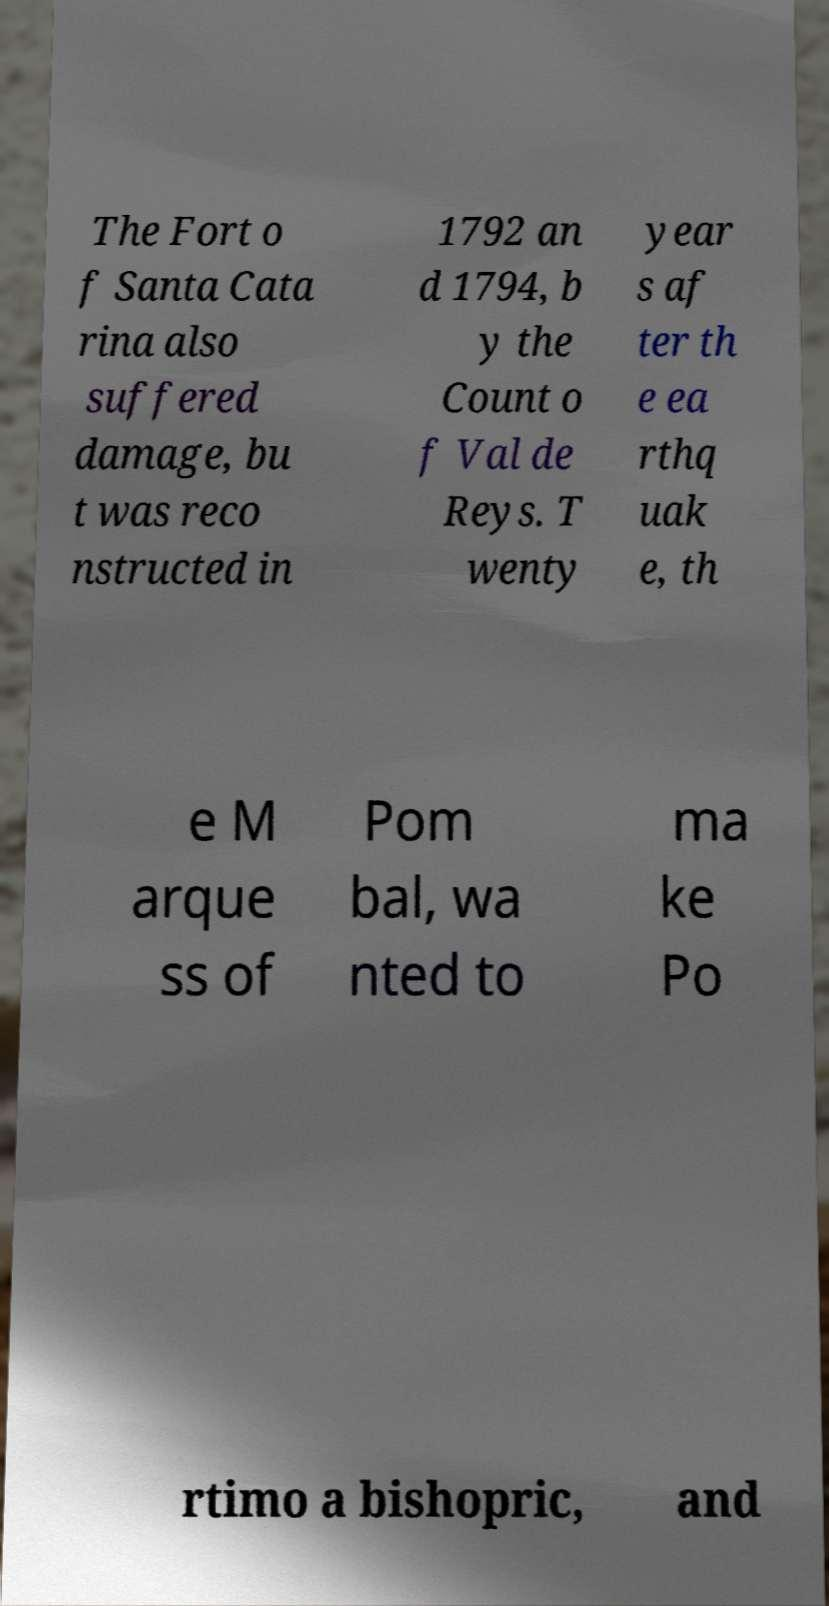For documentation purposes, I need the text within this image transcribed. Could you provide that? The Fort o f Santa Cata rina also suffered damage, bu t was reco nstructed in 1792 an d 1794, b y the Count o f Val de Reys. T wenty year s af ter th e ea rthq uak e, th e M arque ss of Pom bal, wa nted to ma ke Po rtimo a bishopric, and 